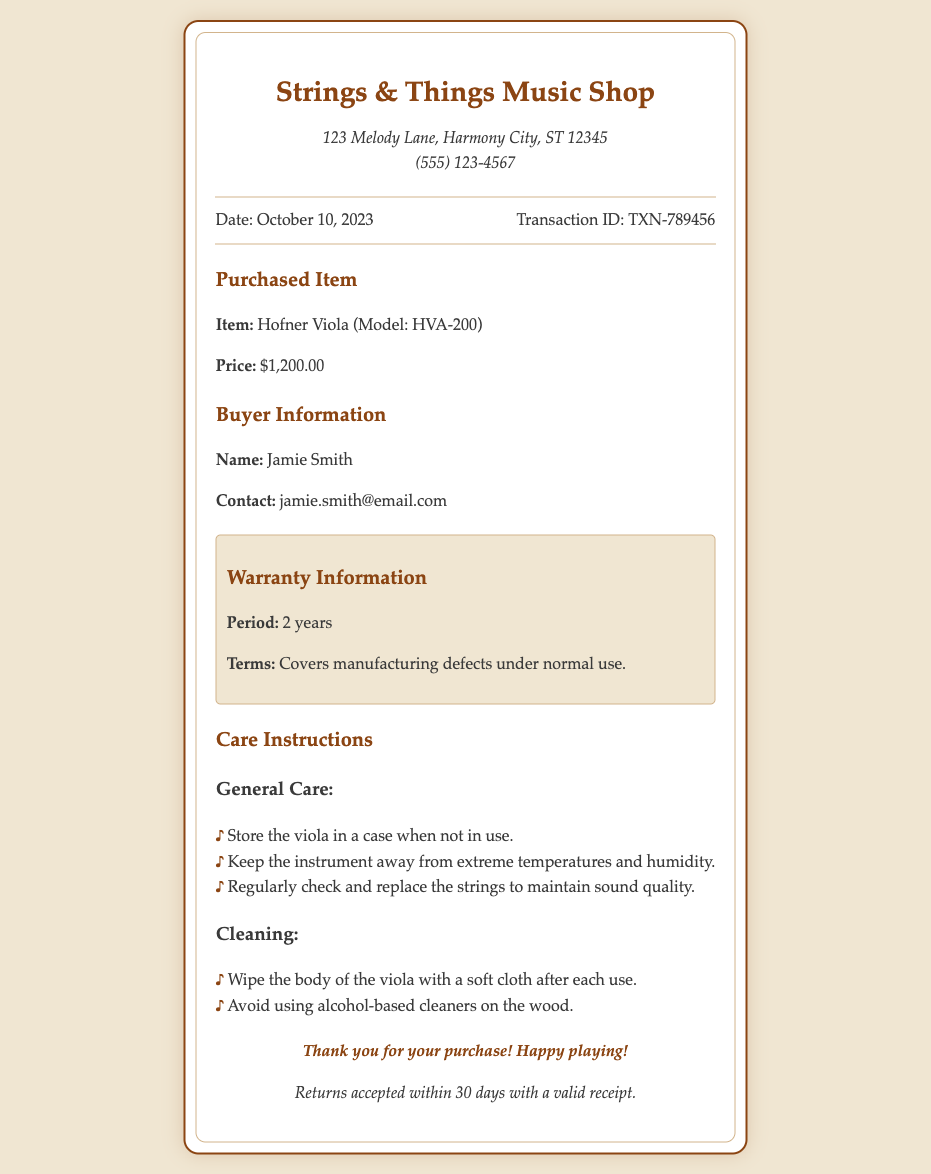What is the store name? The store name is prominently displayed at the top of the receipt.
Answer: Strings & Things Music Shop What was the purchase date? The purchase date is indicated in the transaction information section.
Answer: October 10, 2023 What is the model of the viola purchased? The model of the viola can be found in the item details section of the receipt.
Answer: HVA-200 How much did the viola cost? The price of the viola is listed directly under the item description.
Answer: $1,200.00 What is the warranty period? The warranty information specifies the duration of the warranty.
Answer: 2 years What is the contact email for the buyer? The buyer's contact email is provided in the buyer information section.
Answer: jamie.smith@email.com What should you do after each use of the viola? The care instructions outline post-use actions for maintaining the viola.
Answer: Wipe the body of the viola with a soft cloth How long do you have to return the viola? The return policy is mentioned in the footer of the receipt.
Answer: 30 days What is covered under the warranty? The terms of the warranty cover specific scenarios as described in the warranty information.
Answer: Manufacturing defects under normal use 